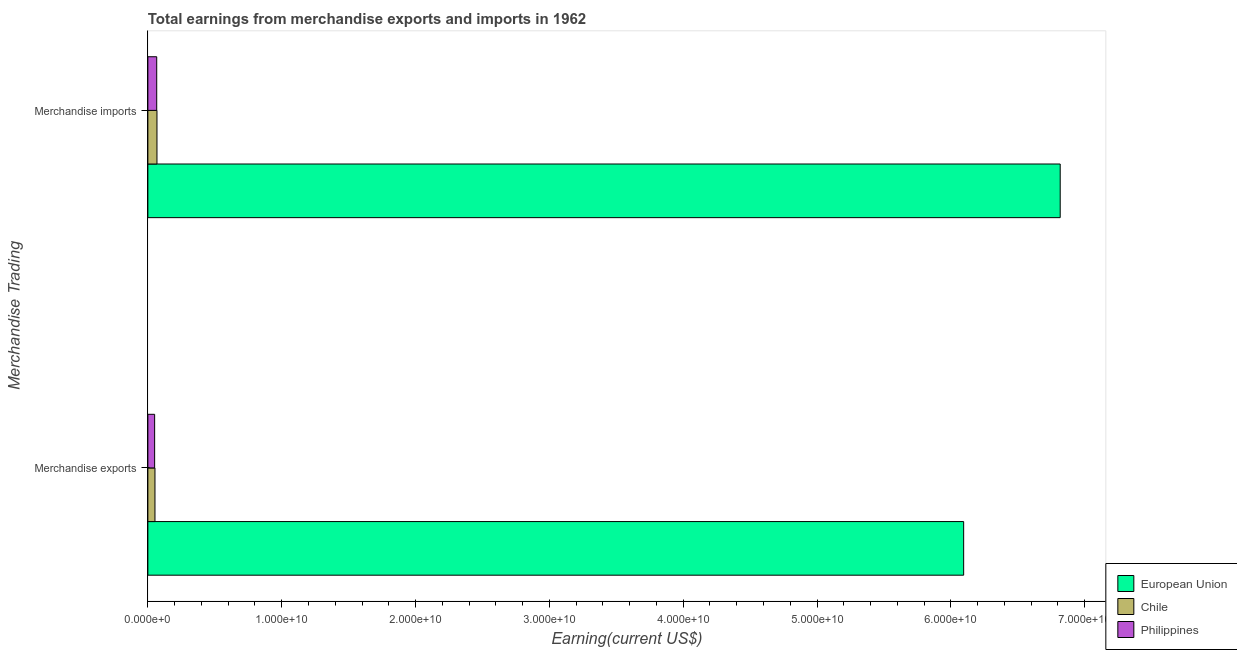How many different coloured bars are there?
Offer a terse response. 3. How many groups of bars are there?
Offer a very short reply. 2. Are the number of bars per tick equal to the number of legend labels?
Give a very brief answer. Yes. How many bars are there on the 2nd tick from the bottom?
Your answer should be very brief. 3. What is the label of the 2nd group of bars from the top?
Your answer should be very brief. Merchandise exports. What is the earnings from merchandise exports in European Union?
Your answer should be very brief. 6.10e+1. Across all countries, what is the maximum earnings from merchandise exports?
Provide a short and direct response. 6.10e+1. Across all countries, what is the minimum earnings from merchandise imports?
Offer a very short reply. 6.61e+08. What is the total earnings from merchandise imports in the graph?
Your answer should be compact. 6.95e+1. What is the difference between the earnings from merchandise exports in European Union and that in Philippines?
Provide a short and direct response. 6.04e+1. What is the difference between the earnings from merchandise exports in Chile and the earnings from merchandise imports in Philippines?
Ensure brevity in your answer.  -1.31e+08. What is the average earnings from merchandise imports per country?
Your answer should be very brief. 2.32e+1. What is the difference between the earnings from merchandise exports and earnings from merchandise imports in Chile?
Keep it short and to the point. -1.50e+08. What is the ratio of the earnings from merchandise imports in Chile to that in European Union?
Offer a very short reply. 0.01. What does the 2nd bar from the top in Merchandise imports represents?
Offer a terse response. Chile. What does the 3rd bar from the bottom in Merchandise exports represents?
Offer a very short reply. Philippines. How many bars are there?
Your answer should be compact. 6. Are all the bars in the graph horizontal?
Offer a very short reply. Yes. What is the difference between two consecutive major ticks on the X-axis?
Your response must be concise. 1.00e+1. Are the values on the major ticks of X-axis written in scientific E-notation?
Give a very brief answer. Yes. How are the legend labels stacked?
Your response must be concise. Vertical. What is the title of the graph?
Offer a terse response. Total earnings from merchandise exports and imports in 1962. What is the label or title of the X-axis?
Your response must be concise. Earning(current US$). What is the label or title of the Y-axis?
Offer a very short reply. Merchandise Trading. What is the Earning(current US$) of European Union in Merchandise exports?
Provide a succinct answer. 6.10e+1. What is the Earning(current US$) of Chile in Merchandise exports?
Your answer should be compact. 5.30e+08. What is the Earning(current US$) of Philippines in Merchandise exports?
Provide a succinct answer. 5.07e+08. What is the Earning(current US$) of European Union in Merchandise imports?
Give a very brief answer. 6.82e+1. What is the Earning(current US$) of Chile in Merchandise imports?
Your answer should be compact. 6.80e+08. What is the Earning(current US$) of Philippines in Merchandise imports?
Keep it short and to the point. 6.61e+08. Across all Merchandise Trading, what is the maximum Earning(current US$) in European Union?
Your answer should be compact. 6.82e+1. Across all Merchandise Trading, what is the maximum Earning(current US$) in Chile?
Keep it short and to the point. 6.80e+08. Across all Merchandise Trading, what is the maximum Earning(current US$) in Philippines?
Keep it short and to the point. 6.61e+08. Across all Merchandise Trading, what is the minimum Earning(current US$) of European Union?
Your answer should be very brief. 6.10e+1. Across all Merchandise Trading, what is the minimum Earning(current US$) in Chile?
Offer a terse response. 5.30e+08. Across all Merchandise Trading, what is the minimum Earning(current US$) in Philippines?
Keep it short and to the point. 5.07e+08. What is the total Earning(current US$) of European Union in the graph?
Your answer should be compact. 1.29e+11. What is the total Earning(current US$) in Chile in the graph?
Offer a terse response. 1.21e+09. What is the total Earning(current US$) of Philippines in the graph?
Provide a short and direct response. 1.17e+09. What is the difference between the Earning(current US$) of European Union in Merchandise exports and that in Merchandise imports?
Provide a short and direct response. -7.21e+09. What is the difference between the Earning(current US$) in Chile in Merchandise exports and that in Merchandise imports?
Keep it short and to the point. -1.50e+08. What is the difference between the Earning(current US$) of Philippines in Merchandise exports and that in Merchandise imports?
Offer a terse response. -1.55e+08. What is the difference between the Earning(current US$) of European Union in Merchandise exports and the Earning(current US$) of Chile in Merchandise imports?
Offer a terse response. 6.03e+1. What is the difference between the Earning(current US$) in European Union in Merchandise exports and the Earning(current US$) in Philippines in Merchandise imports?
Keep it short and to the point. 6.03e+1. What is the difference between the Earning(current US$) in Chile in Merchandise exports and the Earning(current US$) in Philippines in Merchandise imports?
Give a very brief answer. -1.31e+08. What is the average Earning(current US$) of European Union per Merchandise Trading?
Your response must be concise. 6.46e+1. What is the average Earning(current US$) in Chile per Merchandise Trading?
Offer a very short reply. 6.05e+08. What is the average Earning(current US$) in Philippines per Merchandise Trading?
Your response must be concise. 5.84e+08. What is the difference between the Earning(current US$) in European Union and Earning(current US$) in Chile in Merchandise exports?
Provide a succinct answer. 6.04e+1. What is the difference between the Earning(current US$) of European Union and Earning(current US$) of Philippines in Merchandise exports?
Ensure brevity in your answer.  6.04e+1. What is the difference between the Earning(current US$) of Chile and Earning(current US$) of Philippines in Merchandise exports?
Make the answer very short. 2.36e+07. What is the difference between the Earning(current US$) in European Union and Earning(current US$) in Chile in Merchandise imports?
Offer a terse response. 6.75e+1. What is the difference between the Earning(current US$) in European Union and Earning(current US$) in Philippines in Merchandise imports?
Make the answer very short. 6.75e+1. What is the difference between the Earning(current US$) of Chile and Earning(current US$) of Philippines in Merchandise imports?
Your answer should be compact. 1.86e+07. What is the ratio of the Earning(current US$) of European Union in Merchandise exports to that in Merchandise imports?
Make the answer very short. 0.89. What is the ratio of the Earning(current US$) in Chile in Merchandise exports to that in Merchandise imports?
Offer a very short reply. 0.78. What is the ratio of the Earning(current US$) of Philippines in Merchandise exports to that in Merchandise imports?
Your response must be concise. 0.77. What is the difference between the highest and the second highest Earning(current US$) of European Union?
Keep it short and to the point. 7.21e+09. What is the difference between the highest and the second highest Earning(current US$) in Chile?
Your answer should be very brief. 1.50e+08. What is the difference between the highest and the second highest Earning(current US$) in Philippines?
Your answer should be very brief. 1.55e+08. What is the difference between the highest and the lowest Earning(current US$) in European Union?
Make the answer very short. 7.21e+09. What is the difference between the highest and the lowest Earning(current US$) of Chile?
Give a very brief answer. 1.50e+08. What is the difference between the highest and the lowest Earning(current US$) in Philippines?
Offer a terse response. 1.55e+08. 